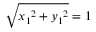Convert formula to latex. <formula><loc_0><loc_0><loc_500><loc_500>{ \sqrt { { x _ { 1 } } ^ { 2 } + { y _ { 1 } } ^ { 2 } } } = 1</formula> 